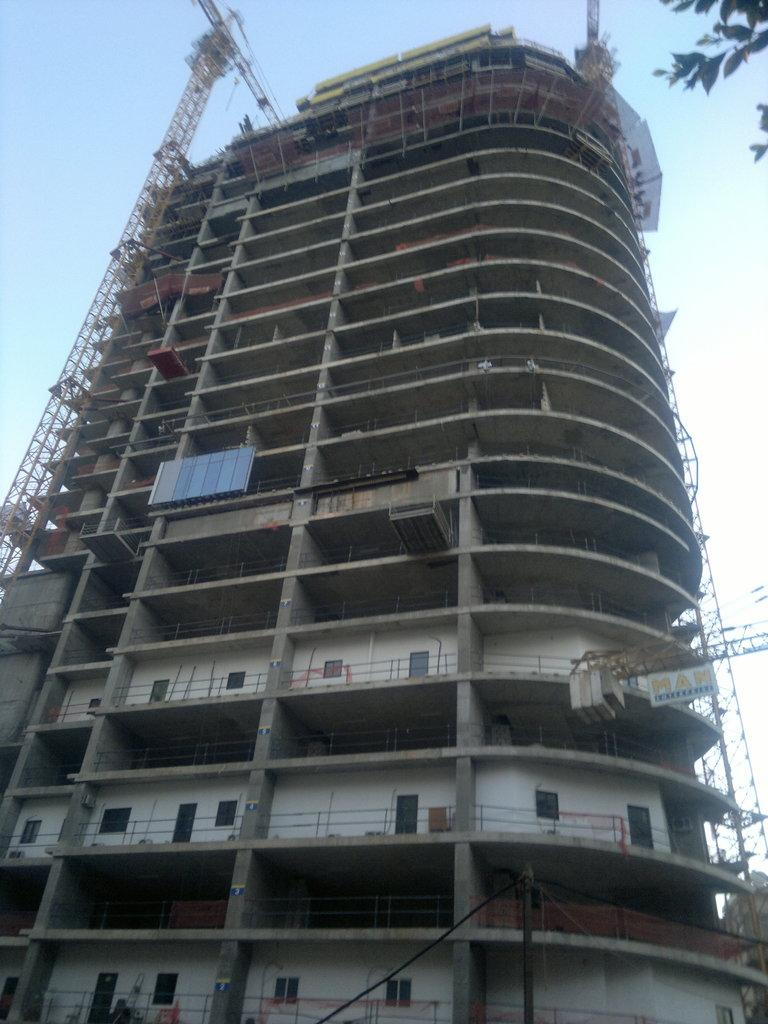What is the main subject of the image? The main subject of the image is a building under construction. What equipment is being used for the construction? There are two crane machines in the image. What type of vegetation can be seen in the image? There are leaves visible in the image. What is visible at the top of the image? The sky is visible at the top of the image. What type of band is performing in the image? There is no band present in the image; it features a building under construction and two crane machines. Can you see a tent in the image? There is no tent present in the image. 